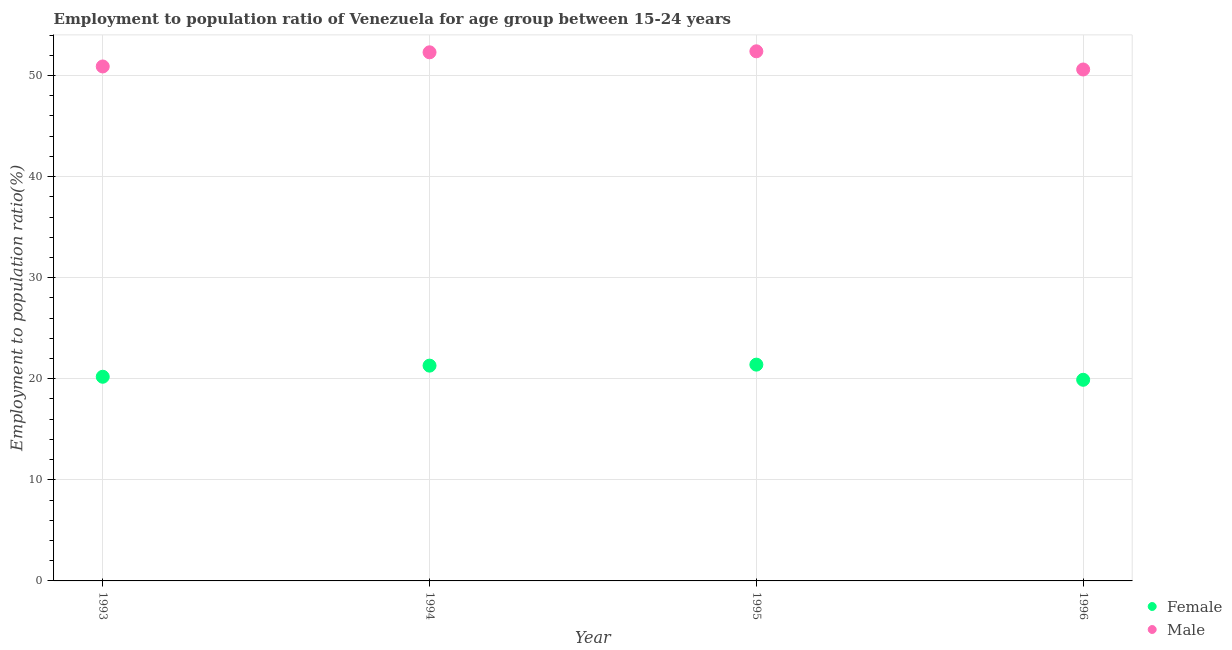What is the employment to population ratio(female) in 1996?
Your answer should be compact. 19.9. Across all years, what is the maximum employment to population ratio(female)?
Provide a succinct answer. 21.4. Across all years, what is the minimum employment to population ratio(female)?
Provide a short and direct response. 19.9. In which year was the employment to population ratio(male) maximum?
Keep it short and to the point. 1995. In which year was the employment to population ratio(female) minimum?
Ensure brevity in your answer.  1996. What is the total employment to population ratio(male) in the graph?
Keep it short and to the point. 206.2. What is the difference between the employment to population ratio(male) in 1993 and that in 1994?
Provide a succinct answer. -1.4. What is the difference between the employment to population ratio(female) in 1993 and the employment to population ratio(male) in 1996?
Make the answer very short. -30.4. What is the average employment to population ratio(female) per year?
Make the answer very short. 20.7. In the year 1996, what is the difference between the employment to population ratio(female) and employment to population ratio(male)?
Provide a short and direct response. -30.7. In how many years, is the employment to population ratio(male) greater than 14 %?
Ensure brevity in your answer.  4. What is the ratio of the employment to population ratio(male) in 1993 to that in 1996?
Ensure brevity in your answer.  1.01. Is the employment to population ratio(female) in 1993 less than that in 1995?
Your response must be concise. Yes. What is the difference between the highest and the second highest employment to population ratio(female)?
Provide a short and direct response. 0.1. What is the difference between the highest and the lowest employment to population ratio(female)?
Provide a short and direct response. 1.5. Is the sum of the employment to population ratio(male) in 1995 and 1996 greater than the maximum employment to population ratio(female) across all years?
Offer a terse response. Yes. Does the employment to population ratio(female) monotonically increase over the years?
Give a very brief answer. No. Is the employment to population ratio(male) strictly greater than the employment to population ratio(female) over the years?
Keep it short and to the point. Yes. How many years are there in the graph?
Provide a succinct answer. 4. Does the graph contain any zero values?
Ensure brevity in your answer.  No. Where does the legend appear in the graph?
Provide a succinct answer. Bottom right. How are the legend labels stacked?
Offer a terse response. Vertical. What is the title of the graph?
Offer a very short reply. Employment to population ratio of Venezuela for age group between 15-24 years. Does "Non-pregnant women" appear as one of the legend labels in the graph?
Your answer should be very brief. No. What is the label or title of the X-axis?
Provide a succinct answer. Year. What is the label or title of the Y-axis?
Provide a short and direct response. Employment to population ratio(%). What is the Employment to population ratio(%) in Female in 1993?
Give a very brief answer. 20.2. What is the Employment to population ratio(%) of Male in 1993?
Offer a very short reply. 50.9. What is the Employment to population ratio(%) of Female in 1994?
Provide a short and direct response. 21.3. What is the Employment to population ratio(%) in Male in 1994?
Offer a very short reply. 52.3. What is the Employment to population ratio(%) in Female in 1995?
Provide a succinct answer. 21.4. What is the Employment to population ratio(%) in Male in 1995?
Give a very brief answer. 52.4. What is the Employment to population ratio(%) of Female in 1996?
Provide a succinct answer. 19.9. What is the Employment to population ratio(%) in Male in 1996?
Give a very brief answer. 50.6. Across all years, what is the maximum Employment to population ratio(%) of Female?
Your answer should be compact. 21.4. Across all years, what is the maximum Employment to population ratio(%) in Male?
Ensure brevity in your answer.  52.4. Across all years, what is the minimum Employment to population ratio(%) in Female?
Keep it short and to the point. 19.9. Across all years, what is the minimum Employment to population ratio(%) of Male?
Your response must be concise. 50.6. What is the total Employment to population ratio(%) of Female in the graph?
Your answer should be very brief. 82.8. What is the total Employment to population ratio(%) in Male in the graph?
Your answer should be very brief. 206.2. What is the difference between the Employment to population ratio(%) of Female in 1993 and that in 1995?
Ensure brevity in your answer.  -1.2. What is the difference between the Employment to population ratio(%) of Male in 1993 and that in 1995?
Give a very brief answer. -1.5. What is the difference between the Employment to population ratio(%) in Female in 1993 and that in 1996?
Offer a very short reply. 0.3. What is the difference between the Employment to population ratio(%) of Male in 1993 and that in 1996?
Ensure brevity in your answer.  0.3. What is the difference between the Employment to population ratio(%) of Female in 1994 and that in 1996?
Your response must be concise. 1.4. What is the difference between the Employment to population ratio(%) in Male in 1994 and that in 1996?
Provide a succinct answer. 1.7. What is the difference between the Employment to population ratio(%) in Female in 1995 and that in 1996?
Your answer should be very brief. 1.5. What is the difference between the Employment to population ratio(%) of Male in 1995 and that in 1996?
Keep it short and to the point. 1.8. What is the difference between the Employment to population ratio(%) of Female in 1993 and the Employment to population ratio(%) of Male in 1994?
Provide a short and direct response. -32.1. What is the difference between the Employment to population ratio(%) in Female in 1993 and the Employment to population ratio(%) in Male in 1995?
Your response must be concise. -32.2. What is the difference between the Employment to population ratio(%) of Female in 1993 and the Employment to population ratio(%) of Male in 1996?
Keep it short and to the point. -30.4. What is the difference between the Employment to population ratio(%) of Female in 1994 and the Employment to population ratio(%) of Male in 1995?
Offer a very short reply. -31.1. What is the difference between the Employment to population ratio(%) of Female in 1994 and the Employment to population ratio(%) of Male in 1996?
Provide a short and direct response. -29.3. What is the difference between the Employment to population ratio(%) of Female in 1995 and the Employment to population ratio(%) of Male in 1996?
Make the answer very short. -29.2. What is the average Employment to population ratio(%) in Female per year?
Provide a short and direct response. 20.7. What is the average Employment to population ratio(%) of Male per year?
Your response must be concise. 51.55. In the year 1993, what is the difference between the Employment to population ratio(%) in Female and Employment to population ratio(%) in Male?
Provide a short and direct response. -30.7. In the year 1994, what is the difference between the Employment to population ratio(%) in Female and Employment to population ratio(%) in Male?
Give a very brief answer. -31. In the year 1995, what is the difference between the Employment to population ratio(%) in Female and Employment to population ratio(%) in Male?
Offer a very short reply. -31. In the year 1996, what is the difference between the Employment to population ratio(%) of Female and Employment to population ratio(%) of Male?
Ensure brevity in your answer.  -30.7. What is the ratio of the Employment to population ratio(%) in Female in 1993 to that in 1994?
Keep it short and to the point. 0.95. What is the ratio of the Employment to population ratio(%) of Male in 1993 to that in 1994?
Offer a terse response. 0.97. What is the ratio of the Employment to population ratio(%) in Female in 1993 to that in 1995?
Give a very brief answer. 0.94. What is the ratio of the Employment to population ratio(%) of Male in 1993 to that in 1995?
Offer a very short reply. 0.97. What is the ratio of the Employment to population ratio(%) in Female in 1993 to that in 1996?
Ensure brevity in your answer.  1.02. What is the ratio of the Employment to population ratio(%) of Male in 1993 to that in 1996?
Provide a succinct answer. 1.01. What is the ratio of the Employment to population ratio(%) in Male in 1994 to that in 1995?
Your response must be concise. 1. What is the ratio of the Employment to population ratio(%) in Female in 1994 to that in 1996?
Your answer should be compact. 1.07. What is the ratio of the Employment to population ratio(%) in Male in 1994 to that in 1996?
Offer a terse response. 1.03. What is the ratio of the Employment to population ratio(%) in Female in 1995 to that in 1996?
Ensure brevity in your answer.  1.08. What is the ratio of the Employment to population ratio(%) in Male in 1995 to that in 1996?
Your answer should be very brief. 1.04. What is the difference between the highest and the second highest Employment to population ratio(%) in Female?
Give a very brief answer. 0.1. What is the difference between the highest and the second highest Employment to population ratio(%) in Male?
Provide a short and direct response. 0.1. 